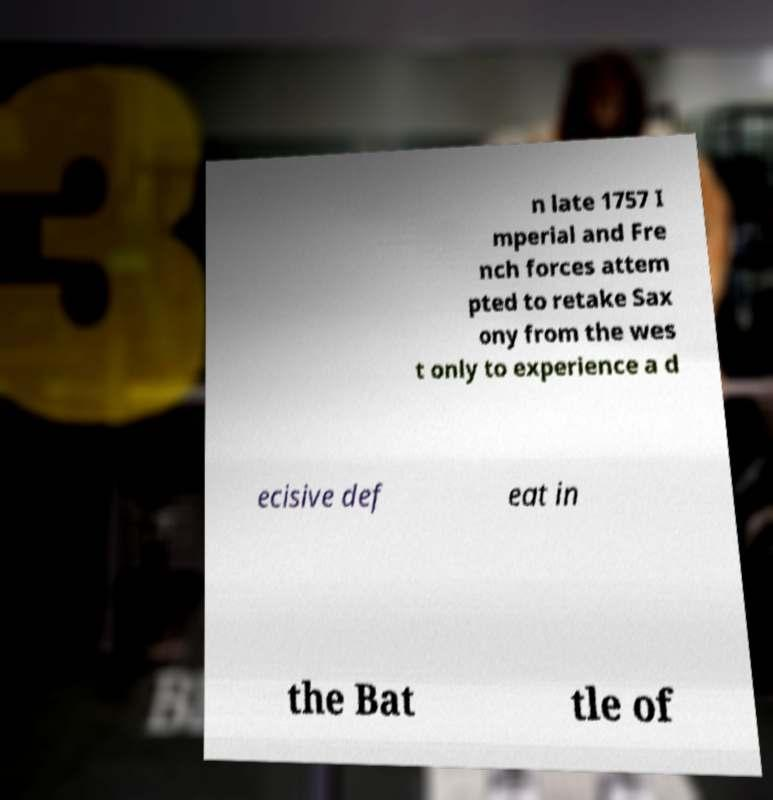I need the written content from this picture converted into text. Can you do that? n late 1757 I mperial and Fre nch forces attem pted to retake Sax ony from the wes t only to experience a d ecisive def eat in the Bat tle of 